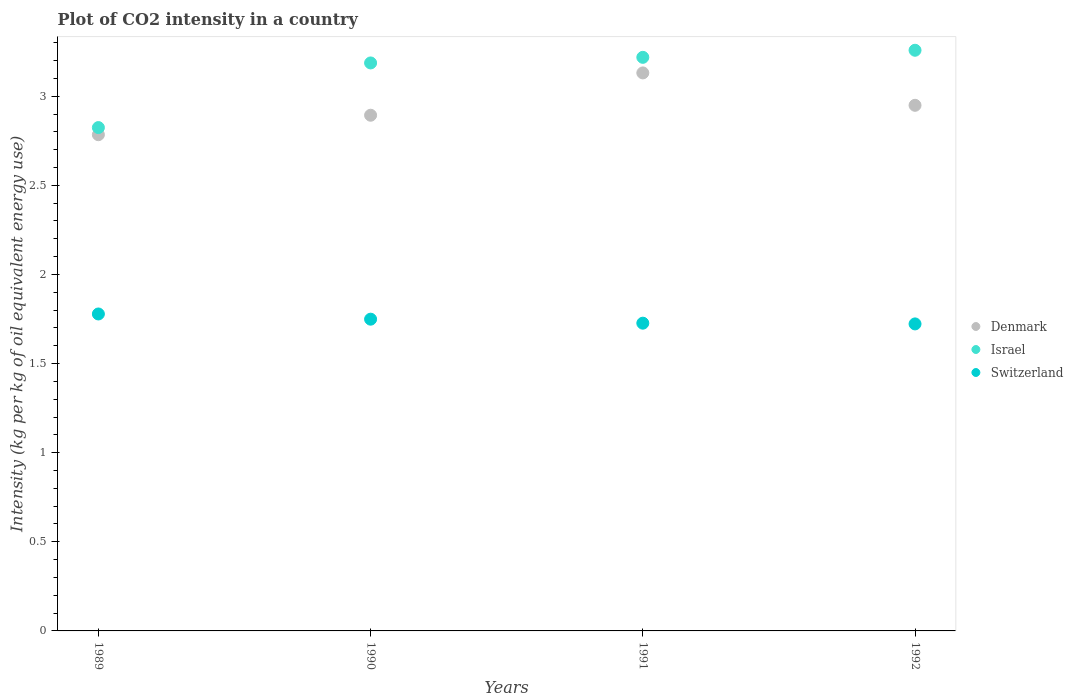Is the number of dotlines equal to the number of legend labels?
Keep it short and to the point. Yes. What is the CO2 intensity in in Switzerland in 1989?
Ensure brevity in your answer.  1.78. Across all years, what is the maximum CO2 intensity in in Switzerland?
Provide a short and direct response. 1.78. Across all years, what is the minimum CO2 intensity in in Israel?
Your answer should be compact. 2.82. In which year was the CO2 intensity in in Denmark minimum?
Your response must be concise. 1989. What is the total CO2 intensity in in Denmark in the graph?
Provide a succinct answer. 11.76. What is the difference between the CO2 intensity in in Switzerland in 1989 and that in 1991?
Your answer should be very brief. 0.05. What is the difference between the CO2 intensity in in Denmark in 1992 and the CO2 intensity in in Switzerland in 1990?
Make the answer very short. 1.2. What is the average CO2 intensity in in Denmark per year?
Your answer should be very brief. 2.94. In the year 1990, what is the difference between the CO2 intensity in in Denmark and CO2 intensity in in Switzerland?
Offer a very short reply. 1.14. What is the ratio of the CO2 intensity in in Israel in 1991 to that in 1992?
Make the answer very short. 0.99. What is the difference between the highest and the second highest CO2 intensity in in Denmark?
Give a very brief answer. 0.18. What is the difference between the highest and the lowest CO2 intensity in in Switzerland?
Your response must be concise. 0.06. In how many years, is the CO2 intensity in in Denmark greater than the average CO2 intensity in in Denmark taken over all years?
Offer a terse response. 2. Does the CO2 intensity in in Israel monotonically increase over the years?
Your response must be concise. Yes. Is the CO2 intensity in in Switzerland strictly greater than the CO2 intensity in in Denmark over the years?
Ensure brevity in your answer.  No. How many dotlines are there?
Your answer should be compact. 3. How many years are there in the graph?
Give a very brief answer. 4. How many legend labels are there?
Your answer should be very brief. 3. How are the legend labels stacked?
Ensure brevity in your answer.  Vertical. What is the title of the graph?
Offer a very short reply. Plot of CO2 intensity in a country. What is the label or title of the X-axis?
Your answer should be very brief. Years. What is the label or title of the Y-axis?
Give a very brief answer. Intensity (kg per kg of oil equivalent energy use). What is the Intensity (kg per kg of oil equivalent energy use) in Denmark in 1989?
Offer a terse response. 2.78. What is the Intensity (kg per kg of oil equivalent energy use) of Israel in 1989?
Make the answer very short. 2.82. What is the Intensity (kg per kg of oil equivalent energy use) of Switzerland in 1989?
Make the answer very short. 1.78. What is the Intensity (kg per kg of oil equivalent energy use) in Denmark in 1990?
Your answer should be very brief. 2.89. What is the Intensity (kg per kg of oil equivalent energy use) of Israel in 1990?
Your answer should be compact. 3.19. What is the Intensity (kg per kg of oil equivalent energy use) of Switzerland in 1990?
Make the answer very short. 1.75. What is the Intensity (kg per kg of oil equivalent energy use) in Denmark in 1991?
Your response must be concise. 3.13. What is the Intensity (kg per kg of oil equivalent energy use) in Israel in 1991?
Ensure brevity in your answer.  3.22. What is the Intensity (kg per kg of oil equivalent energy use) in Switzerland in 1991?
Your response must be concise. 1.73. What is the Intensity (kg per kg of oil equivalent energy use) in Denmark in 1992?
Your answer should be very brief. 2.95. What is the Intensity (kg per kg of oil equivalent energy use) of Israel in 1992?
Your answer should be compact. 3.26. What is the Intensity (kg per kg of oil equivalent energy use) in Switzerland in 1992?
Give a very brief answer. 1.72. Across all years, what is the maximum Intensity (kg per kg of oil equivalent energy use) of Denmark?
Give a very brief answer. 3.13. Across all years, what is the maximum Intensity (kg per kg of oil equivalent energy use) of Israel?
Keep it short and to the point. 3.26. Across all years, what is the maximum Intensity (kg per kg of oil equivalent energy use) of Switzerland?
Ensure brevity in your answer.  1.78. Across all years, what is the minimum Intensity (kg per kg of oil equivalent energy use) in Denmark?
Your response must be concise. 2.78. Across all years, what is the minimum Intensity (kg per kg of oil equivalent energy use) in Israel?
Keep it short and to the point. 2.82. Across all years, what is the minimum Intensity (kg per kg of oil equivalent energy use) of Switzerland?
Offer a very short reply. 1.72. What is the total Intensity (kg per kg of oil equivalent energy use) of Denmark in the graph?
Provide a succinct answer. 11.76. What is the total Intensity (kg per kg of oil equivalent energy use) of Israel in the graph?
Offer a terse response. 12.49. What is the total Intensity (kg per kg of oil equivalent energy use) in Switzerland in the graph?
Give a very brief answer. 6.98. What is the difference between the Intensity (kg per kg of oil equivalent energy use) of Denmark in 1989 and that in 1990?
Offer a terse response. -0.11. What is the difference between the Intensity (kg per kg of oil equivalent energy use) of Israel in 1989 and that in 1990?
Offer a very short reply. -0.36. What is the difference between the Intensity (kg per kg of oil equivalent energy use) of Switzerland in 1989 and that in 1990?
Your answer should be compact. 0.03. What is the difference between the Intensity (kg per kg of oil equivalent energy use) in Denmark in 1989 and that in 1991?
Your answer should be very brief. -0.35. What is the difference between the Intensity (kg per kg of oil equivalent energy use) of Israel in 1989 and that in 1991?
Offer a terse response. -0.39. What is the difference between the Intensity (kg per kg of oil equivalent energy use) in Switzerland in 1989 and that in 1991?
Provide a succinct answer. 0.05. What is the difference between the Intensity (kg per kg of oil equivalent energy use) of Denmark in 1989 and that in 1992?
Keep it short and to the point. -0.17. What is the difference between the Intensity (kg per kg of oil equivalent energy use) of Israel in 1989 and that in 1992?
Your answer should be compact. -0.43. What is the difference between the Intensity (kg per kg of oil equivalent energy use) in Switzerland in 1989 and that in 1992?
Provide a short and direct response. 0.06. What is the difference between the Intensity (kg per kg of oil equivalent energy use) of Denmark in 1990 and that in 1991?
Offer a terse response. -0.24. What is the difference between the Intensity (kg per kg of oil equivalent energy use) in Israel in 1990 and that in 1991?
Offer a terse response. -0.03. What is the difference between the Intensity (kg per kg of oil equivalent energy use) in Switzerland in 1990 and that in 1991?
Your response must be concise. 0.02. What is the difference between the Intensity (kg per kg of oil equivalent energy use) of Denmark in 1990 and that in 1992?
Your answer should be compact. -0.06. What is the difference between the Intensity (kg per kg of oil equivalent energy use) in Israel in 1990 and that in 1992?
Your answer should be compact. -0.07. What is the difference between the Intensity (kg per kg of oil equivalent energy use) of Switzerland in 1990 and that in 1992?
Provide a succinct answer. 0.03. What is the difference between the Intensity (kg per kg of oil equivalent energy use) of Denmark in 1991 and that in 1992?
Keep it short and to the point. 0.18. What is the difference between the Intensity (kg per kg of oil equivalent energy use) in Israel in 1991 and that in 1992?
Offer a very short reply. -0.04. What is the difference between the Intensity (kg per kg of oil equivalent energy use) in Switzerland in 1991 and that in 1992?
Make the answer very short. 0. What is the difference between the Intensity (kg per kg of oil equivalent energy use) in Denmark in 1989 and the Intensity (kg per kg of oil equivalent energy use) in Israel in 1990?
Give a very brief answer. -0.4. What is the difference between the Intensity (kg per kg of oil equivalent energy use) in Denmark in 1989 and the Intensity (kg per kg of oil equivalent energy use) in Switzerland in 1990?
Give a very brief answer. 1.03. What is the difference between the Intensity (kg per kg of oil equivalent energy use) of Israel in 1989 and the Intensity (kg per kg of oil equivalent energy use) of Switzerland in 1990?
Provide a succinct answer. 1.07. What is the difference between the Intensity (kg per kg of oil equivalent energy use) of Denmark in 1989 and the Intensity (kg per kg of oil equivalent energy use) of Israel in 1991?
Make the answer very short. -0.43. What is the difference between the Intensity (kg per kg of oil equivalent energy use) of Denmark in 1989 and the Intensity (kg per kg of oil equivalent energy use) of Switzerland in 1991?
Offer a very short reply. 1.06. What is the difference between the Intensity (kg per kg of oil equivalent energy use) of Israel in 1989 and the Intensity (kg per kg of oil equivalent energy use) of Switzerland in 1991?
Your answer should be compact. 1.1. What is the difference between the Intensity (kg per kg of oil equivalent energy use) in Denmark in 1989 and the Intensity (kg per kg of oil equivalent energy use) in Israel in 1992?
Offer a terse response. -0.47. What is the difference between the Intensity (kg per kg of oil equivalent energy use) of Denmark in 1989 and the Intensity (kg per kg of oil equivalent energy use) of Switzerland in 1992?
Provide a succinct answer. 1.06. What is the difference between the Intensity (kg per kg of oil equivalent energy use) in Israel in 1989 and the Intensity (kg per kg of oil equivalent energy use) in Switzerland in 1992?
Ensure brevity in your answer.  1.1. What is the difference between the Intensity (kg per kg of oil equivalent energy use) of Denmark in 1990 and the Intensity (kg per kg of oil equivalent energy use) of Israel in 1991?
Provide a succinct answer. -0.32. What is the difference between the Intensity (kg per kg of oil equivalent energy use) in Denmark in 1990 and the Intensity (kg per kg of oil equivalent energy use) in Switzerland in 1991?
Your response must be concise. 1.17. What is the difference between the Intensity (kg per kg of oil equivalent energy use) of Israel in 1990 and the Intensity (kg per kg of oil equivalent energy use) of Switzerland in 1991?
Your answer should be compact. 1.46. What is the difference between the Intensity (kg per kg of oil equivalent energy use) of Denmark in 1990 and the Intensity (kg per kg of oil equivalent energy use) of Israel in 1992?
Your response must be concise. -0.36. What is the difference between the Intensity (kg per kg of oil equivalent energy use) in Denmark in 1990 and the Intensity (kg per kg of oil equivalent energy use) in Switzerland in 1992?
Offer a terse response. 1.17. What is the difference between the Intensity (kg per kg of oil equivalent energy use) of Israel in 1990 and the Intensity (kg per kg of oil equivalent energy use) of Switzerland in 1992?
Your answer should be very brief. 1.46. What is the difference between the Intensity (kg per kg of oil equivalent energy use) of Denmark in 1991 and the Intensity (kg per kg of oil equivalent energy use) of Israel in 1992?
Offer a terse response. -0.13. What is the difference between the Intensity (kg per kg of oil equivalent energy use) in Denmark in 1991 and the Intensity (kg per kg of oil equivalent energy use) in Switzerland in 1992?
Your response must be concise. 1.41. What is the difference between the Intensity (kg per kg of oil equivalent energy use) in Israel in 1991 and the Intensity (kg per kg of oil equivalent energy use) in Switzerland in 1992?
Keep it short and to the point. 1.5. What is the average Intensity (kg per kg of oil equivalent energy use) of Denmark per year?
Your answer should be very brief. 2.94. What is the average Intensity (kg per kg of oil equivalent energy use) of Israel per year?
Give a very brief answer. 3.12. What is the average Intensity (kg per kg of oil equivalent energy use) of Switzerland per year?
Keep it short and to the point. 1.74. In the year 1989, what is the difference between the Intensity (kg per kg of oil equivalent energy use) in Denmark and Intensity (kg per kg of oil equivalent energy use) in Israel?
Offer a terse response. -0.04. In the year 1989, what is the difference between the Intensity (kg per kg of oil equivalent energy use) of Israel and Intensity (kg per kg of oil equivalent energy use) of Switzerland?
Make the answer very short. 1.05. In the year 1990, what is the difference between the Intensity (kg per kg of oil equivalent energy use) of Denmark and Intensity (kg per kg of oil equivalent energy use) of Israel?
Your answer should be compact. -0.29. In the year 1990, what is the difference between the Intensity (kg per kg of oil equivalent energy use) of Denmark and Intensity (kg per kg of oil equivalent energy use) of Switzerland?
Make the answer very short. 1.14. In the year 1990, what is the difference between the Intensity (kg per kg of oil equivalent energy use) of Israel and Intensity (kg per kg of oil equivalent energy use) of Switzerland?
Keep it short and to the point. 1.44. In the year 1991, what is the difference between the Intensity (kg per kg of oil equivalent energy use) in Denmark and Intensity (kg per kg of oil equivalent energy use) in Israel?
Ensure brevity in your answer.  -0.09. In the year 1991, what is the difference between the Intensity (kg per kg of oil equivalent energy use) in Denmark and Intensity (kg per kg of oil equivalent energy use) in Switzerland?
Make the answer very short. 1.4. In the year 1991, what is the difference between the Intensity (kg per kg of oil equivalent energy use) of Israel and Intensity (kg per kg of oil equivalent energy use) of Switzerland?
Ensure brevity in your answer.  1.49. In the year 1992, what is the difference between the Intensity (kg per kg of oil equivalent energy use) of Denmark and Intensity (kg per kg of oil equivalent energy use) of Israel?
Ensure brevity in your answer.  -0.31. In the year 1992, what is the difference between the Intensity (kg per kg of oil equivalent energy use) of Denmark and Intensity (kg per kg of oil equivalent energy use) of Switzerland?
Offer a very short reply. 1.23. In the year 1992, what is the difference between the Intensity (kg per kg of oil equivalent energy use) of Israel and Intensity (kg per kg of oil equivalent energy use) of Switzerland?
Provide a succinct answer. 1.54. What is the ratio of the Intensity (kg per kg of oil equivalent energy use) of Denmark in 1989 to that in 1990?
Your response must be concise. 0.96. What is the ratio of the Intensity (kg per kg of oil equivalent energy use) of Israel in 1989 to that in 1990?
Keep it short and to the point. 0.89. What is the ratio of the Intensity (kg per kg of oil equivalent energy use) of Switzerland in 1989 to that in 1990?
Keep it short and to the point. 1.02. What is the ratio of the Intensity (kg per kg of oil equivalent energy use) in Denmark in 1989 to that in 1991?
Provide a short and direct response. 0.89. What is the ratio of the Intensity (kg per kg of oil equivalent energy use) in Israel in 1989 to that in 1991?
Provide a succinct answer. 0.88. What is the ratio of the Intensity (kg per kg of oil equivalent energy use) in Switzerland in 1989 to that in 1991?
Offer a very short reply. 1.03. What is the ratio of the Intensity (kg per kg of oil equivalent energy use) in Denmark in 1989 to that in 1992?
Your answer should be very brief. 0.94. What is the ratio of the Intensity (kg per kg of oil equivalent energy use) in Israel in 1989 to that in 1992?
Provide a short and direct response. 0.87. What is the ratio of the Intensity (kg per kg of oil equivalent energy use) in Switzerland in 1989 to that in 1992?
Make the answer very short. 1.03. What is the ratio of the Intensity (kg per kg of oil equivalent energy use) in Denmark in 1990 to that in 1991?
Make the answer very short. 0.92. What is the ratio of the Intensity (kg per kg of oil equivalent energy use) of Israel in 1990 to that in 1991?
Offer a very short reply. 0.99. What is the ratio of the Intensity (kg per kg of oil equivalent energy use) in Switzerland in 1990 to that in 1991?
Offer a terse response. 1.01. What is the ratio of the Intensity (kg per kg of oil equivalent energy use) of Denmark in 1990 to that in 1992?
Offer a very short reply. 0.98. What is the ratio of the Intensity (kg per kg of oil equivalent energy use) in Israel in 1990 to that in 1992?
Provide a succinct answer. 0.98. What is the ratio of the Intensity (kg per kg of oil equivalent energy use) of Switzerland in 1990 to that in 1992?
Offer a terse response. 1.02. What is the ratio of the Intensity (kg per kg of oil equivalent energy use) in Denmark in 1991 to that in 1992?
Keep it short and to the point. 1.06. What is the difference between the highest and the second highest Intensity (kg per kg of oil equivalent energy use) of Denmark?
Ensure brevity in your answer.  0.18. What is the difference between the highest and the second highest Intensity (kg per kg of oil equivalent energy use) of Israel?
Provide a short and direct response. 0.04. What is the difference between the highest and the second highest Intensity (kg per kg of oil equivalent energy use) of Switzerland?
Provide a short and direct response. 0.03. What is the difference between the highest and the lowest Intensity (kg per kg of oil equivalent energy use) in Denmark?
Your response must be concise. 0.35. What is the difference between the highest and the lowest Intensity (kg per kg of oil equivalent energy use) in Israel?
Provide a short and direct response. 0.43. What is the difference between the highest and the lowest Intensity (kg per kg of oil equivalent energy use) in Switzerland?
Your answer should be compact. 0.06. 